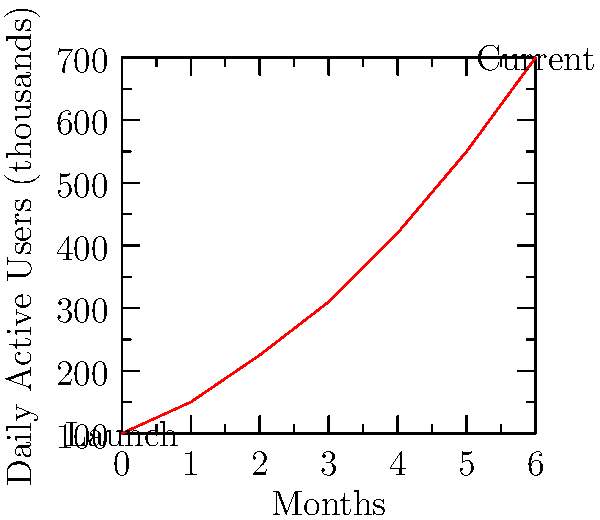Based on the line chart showing the growth trajectory of daily active users for a wellness app over a 6-month period, what is the approximate percentage increase in daily active users from launch to the current month? To calculate the percentage increase in daily active users, we need to follow these steps:

1. Identify the initial (launch) and final (current) values:
   - Initial value at launch: 100,000 users
   - Final value at current month: 700,000 users

2. Calculate the absolute increase:
   $\text{Increase} = \text{Final value} - \text{Initial value}$
   $\text{Increase} = 700,000 - 100,000 = 600,000$

3. Calculate the percentage increase:
   $\text{Percentage increase} = \frac{\text{Increase}}{\text{Initial value}} \times 100\%$
   $\text{Percentage increase} = \frac{600,000}{100,000} \times 100\%$
   $\text{Percentage increase} = 6 \times 100\% = 600\%$

Therefore, the approximate percentage increase in daily active users from launch to the current month is 600%.
Answer: 600% 